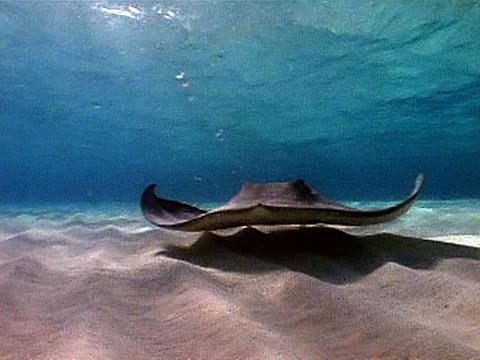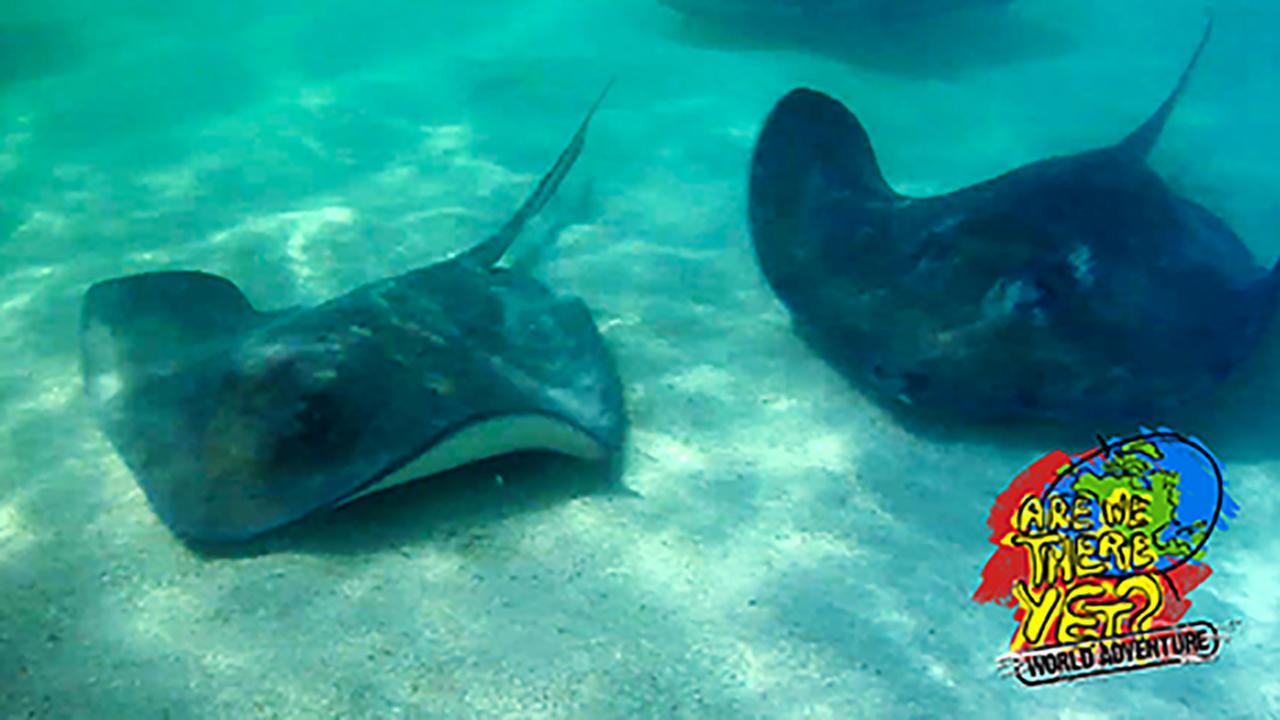The first image is the image on the left, the second image is the image on the right. Considering the images on both sides, is "Two stingray are present in the right image." valid? Answer yes or no. Yes. 